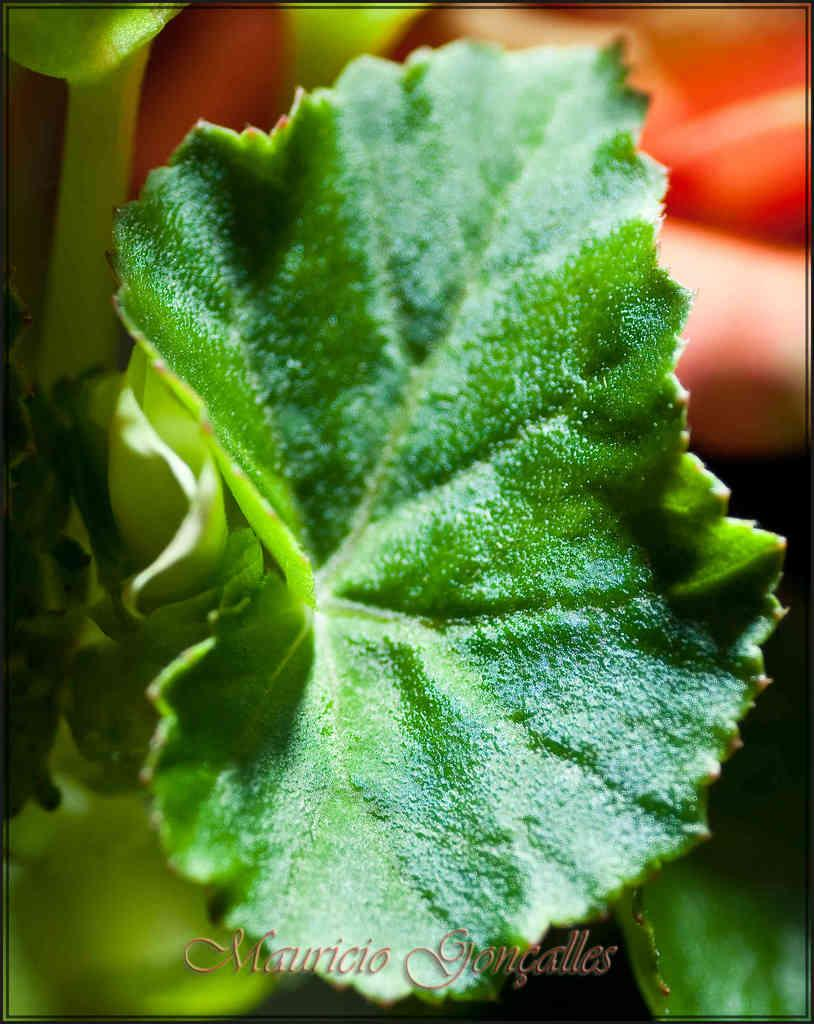What is the main subject of the image? The main subject of the image is a leaf. Can you describe the background of the image? The background of the image is blurred. What type of system is being used to slow down the movement of the leaf in the image? There is no system or movement of the leaf in the image; it is a still image of a leaf with a blurred background. Can you tell me how many brakes are visible in the image? There are no brakes present in the image. 